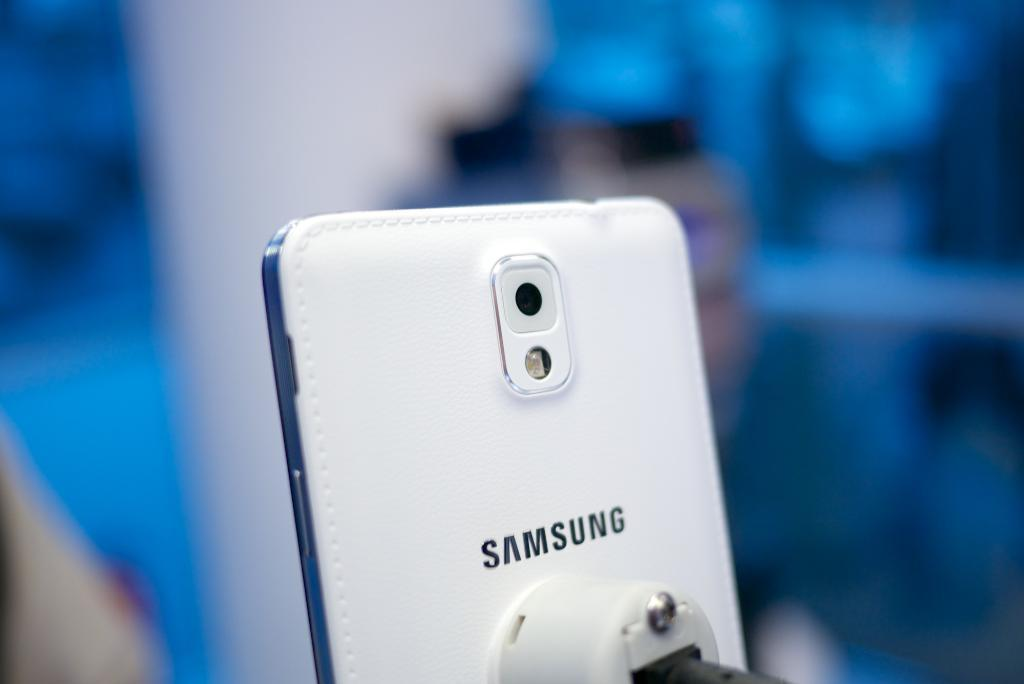<image>
Give a short and clear explanation of the subsequent image. A slim, white Samsung phone is plugged in. 